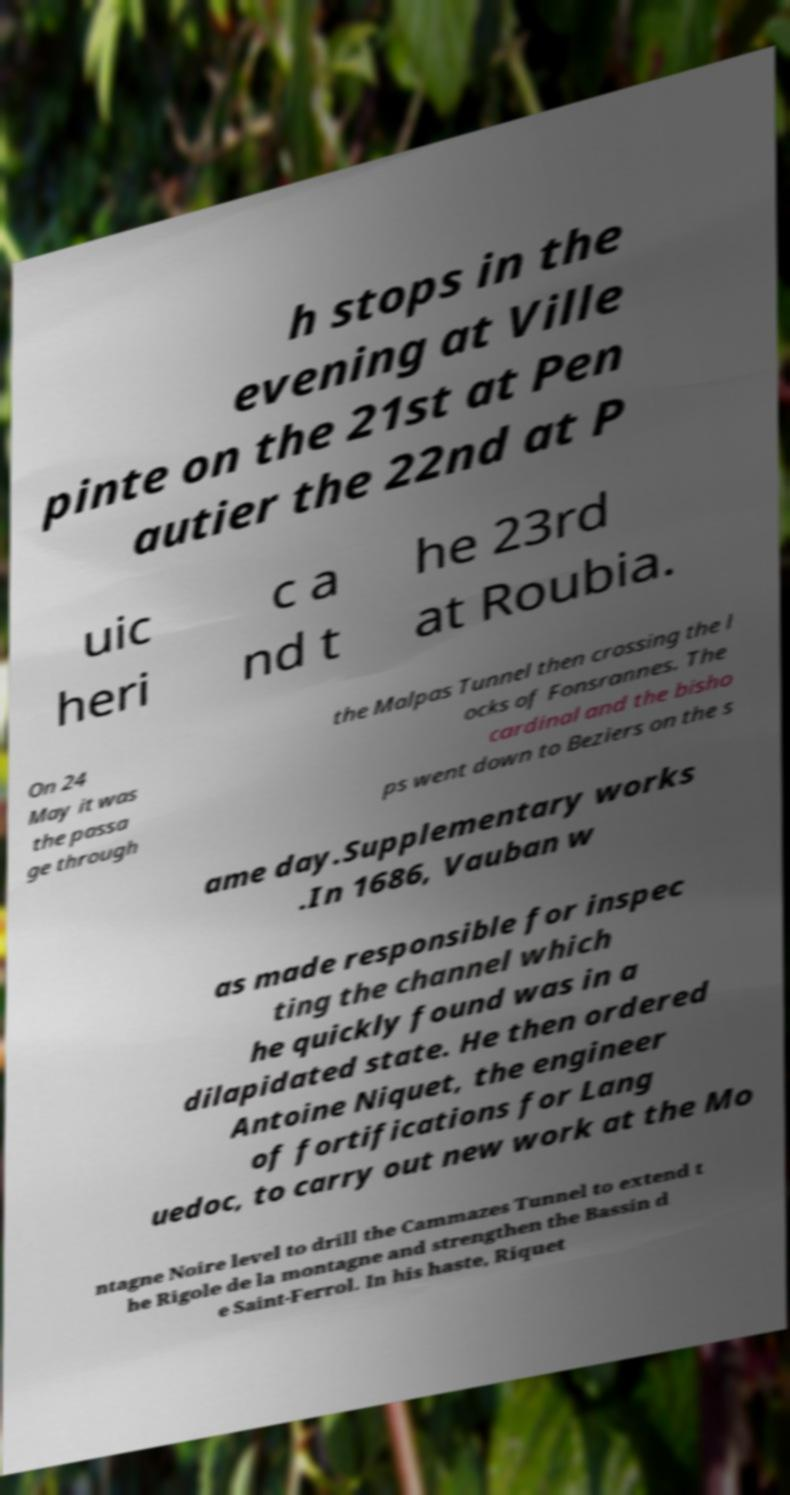For documentation purposes, I need the text within this image transcribed. Could you provide that? h stops in the evening at Ville pinte on the 21st at Pen autier the 22nd at P uic heri c a nd t he 23rd at Roubia. On 24 May it was the passa ge through the Malpas Tunnel then crossing the l ocks of Fonsrannes. The cardinal and the bisho ps went down to Beziers on the s ame day.Supplementary works .In 1686, Vauban w as made responsible for inspec ting the channel which he quickly found was in a dilapidated state. He then ordered Antoine Niquet, the engineer of fortifications for Lang uedoc, to carry out new work at the Mo ntagne Noire level to drill the Cammazes Tunnel to extend t he Rigole de la montagne and strengthen the Bassin d e Saint-Ferrol. In his haste, Riquet 